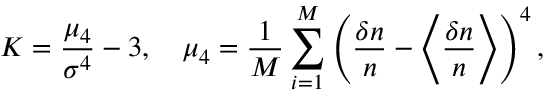<formula> <loc_0><loc_0><loc_500><loc_500>K = \frac { \mu _ { 4 } } { \sigma ^ { 4 } } - 3 , \quad \mu _ { 4 } = \frac { 1 } { M } \sum _ { i = 1 } ^ { M } \left ( \frac { \delta n } { n } - \left \langle \frac { \delta n } { n } \right \rangle \right ) ^ { 4 } ,</formula> 